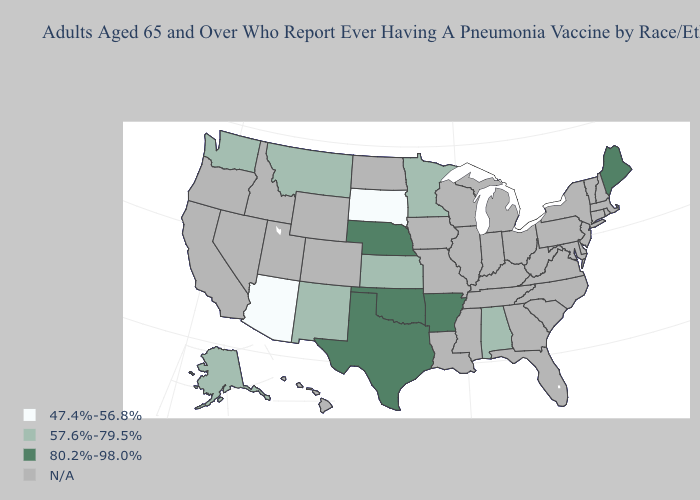Does the first symbol in the legend represent the smallest category?
Quick response, please. Yes. What is the lowest value in states that border Minnesota?
Be succinct. 47.4%-56.8%. Does South Dakota have the lowest value in the USA?
Short answer required. Yes. What is the value of Missouri?
Quick response, please. N/A. What is the value of Utah?
Be succinct. N/A. What is the highest value in the West ?
Answer briefly. 57.6%-79.5%. Which states have the lowest value in the USA?
Quick response, please. Arizona, South Dakota. Name the states that have a value in the range 57.6%-79.5%?
Short answer required. Alabama, Alaska, Kansas, Minnesota, Montana, New Mexico, Washington. What is the value of Colorado?
Keep it brief. N/A. Does Arizona have the highest value in the West?
Be succinct. No. Which states have the lowest value in the MidWest?
Concise answer only. South Dakota. Name the states that have a value in the range 80.2%-98.0%?
Give a very brief answer. Arkansas, Maine, Nebraska, Oklahoma, Texas. 